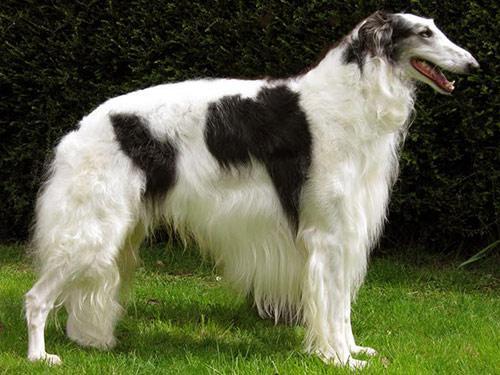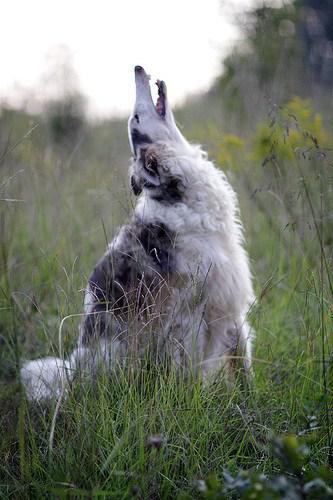The first image is the image on the left, the second image is the image on the right. Considering the images on both sides, is "There are two dogs in the image pair, both facing right." valid? Answer yes or no. Yes. The first image is the image on the left, the second image is the image on the right. Analyze the images presented: Is the assertion "One dog is standing on all fours, and at least one dog has its head raised distinctly upward." valid? Answer yes or no. Yes. 